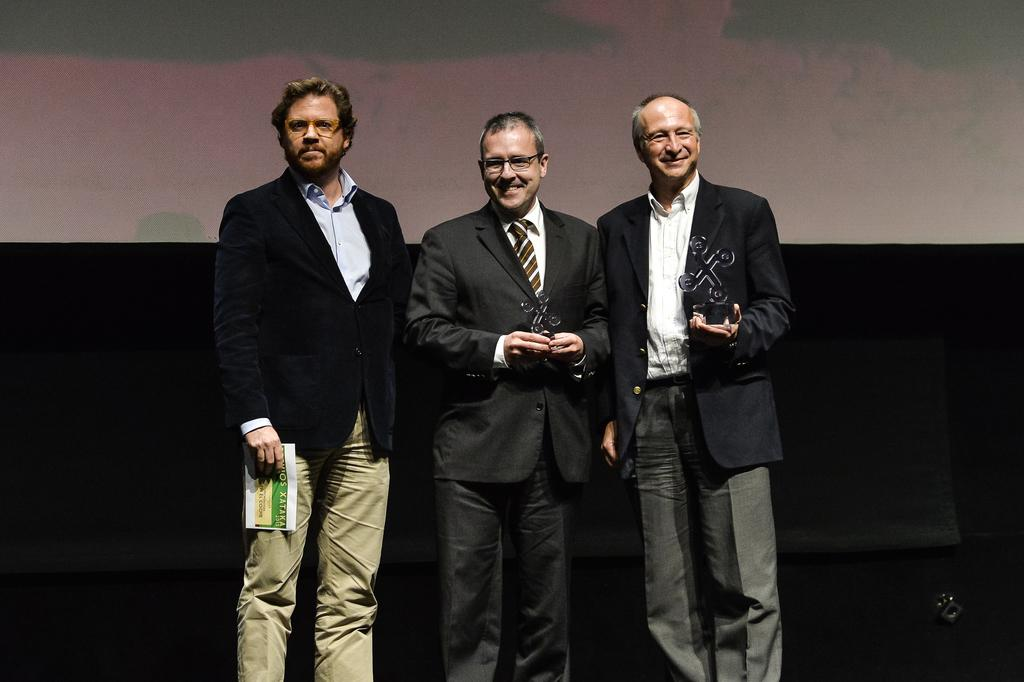How many people are in the image? There are three men in the image. What are the men doing in the image? The men are standing and posing for the picture. What expressions do the men have in the image? The men are smiling in the image. What can be seen in the background of the image? The background of the image is dark. What is present at the top of the image? There is a screen at the top of the image. What type of card is being used by the men in the image? There is no card present in the image; the men are holding objects in their hands, but they are not cards. Can you see a boat in the image? No, there is no boat present in the image. 